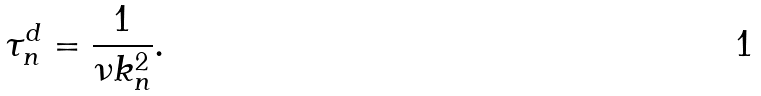Convert formula to latex. <formula><loc_0><loc_0><loc_500><loc_500>\tau ^ { d } _ { n } = \frac { 1 } { \nu k _ { n } ^ { 2 } } .</formula> 